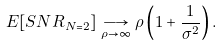<formula> <loc_0><loc_0><loc_500><loc_500>E [ S N R _ { N = 2 } ] \underset { \rho \rightarrow \infty } { \longrightarrow } \rho \left ( 1 + \frac { 1 } { \sigma ^ { 2 } } \right ) .</formula> 